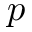<formula> <loc_0><loc_0><loc_500><loc_500>p</formula> 